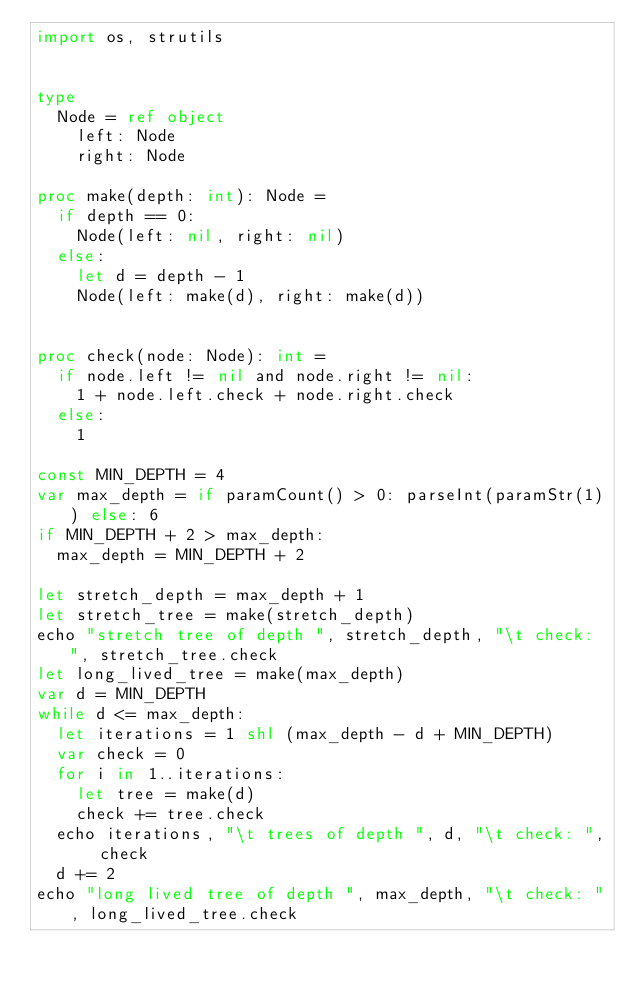<code> <loc_0><loc_0><loc_500><loc_500><_Nim_>import os, strutils


type
  Node = ref object
    left: Node
    right: Node

proc make(depth: int): Node =
  if depth == 0:
    Node(left: nil, right: nil)
  else:
    let d = depth - 1
    Node(left: make(d), right: make(d))


proc check(node: Node): int =
  if node.left != nil and node.right != nil:
    1 + node.left.check + node.right.check
  else:
    1

const MIN_DEPTH = 4
var max_depth = if paramCount() > 0: parseInt(paramStr(1)) else: 6
if MIN_DEPTH + 2 > max_depth:
  max_depth = MIN_DEPTH + 2

let stretch_depth = max_depth + 1
let stretch_tree = make(stretch_depth)
echo "stretch tree of depth ", stretch_depth, "\t check: ", stretch_tree.check
let long_lived_tree = make(max_depth)
var d = MIN_DEPTH
while d <= max_depth:
  let iterations = 1 shl (max_depth - d + MIN_DEPTH)
  var check = 0
  for i in 1..iterations:
    let tree = make(d)
    check += tree.check
  echo iterations, "\t trees of depth ", d, "\t check: ", check
  d += 2
echo "long lived tree of depth ", max_depth, "\t check: ", long_lived_tree.check
</code> 